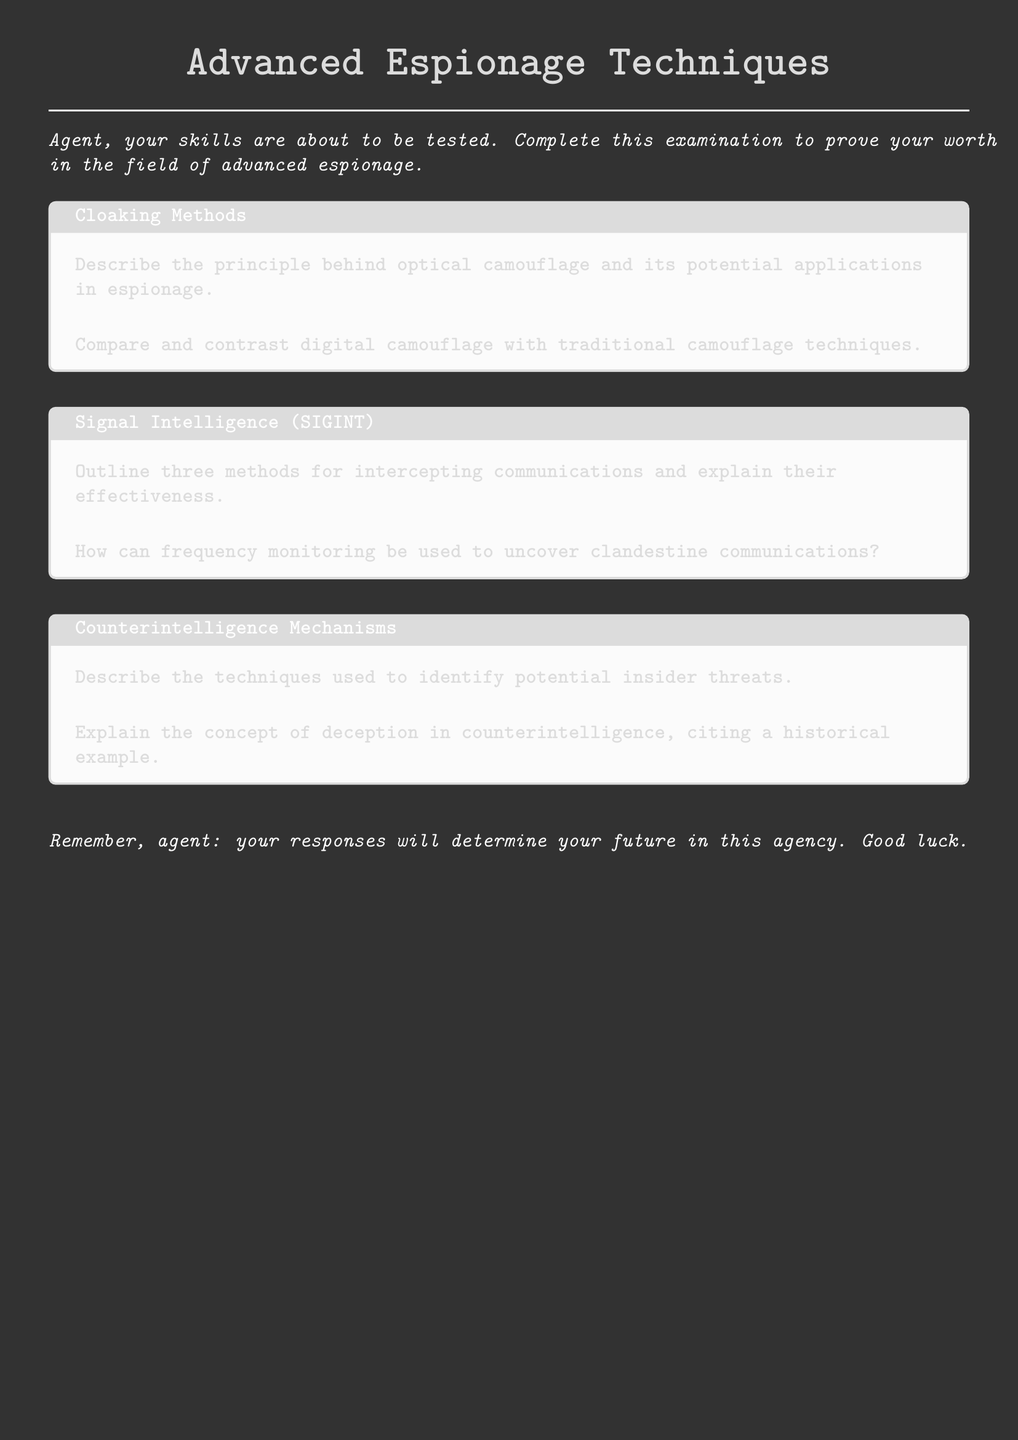What are the areas covered in the exam? The document outlines the areas covered: Cloaking Methods, Signal Intelligence, and Counterintelligence Mechanisms.
Answer: Cloaking Methods, Signal Intelligence, Counterintelligence Mechanisms What is the color scheme of the document? The document features a dark gray background with white text and light gray accents.
Answer: Dark gray background with white text How many methods for intercepting communications are outlined in the document? The document explicitly states three methods for intercepting communications.
Answer: Three methods What historical element is mentioned in the counterintelligence section? The document mentions the concept of deception in counterintelligence, citing a historical example.
Answer: Historical example What font is used in the document? The document specifies the use of "Courier New" as the main font throughout.
Answer: Courier New 